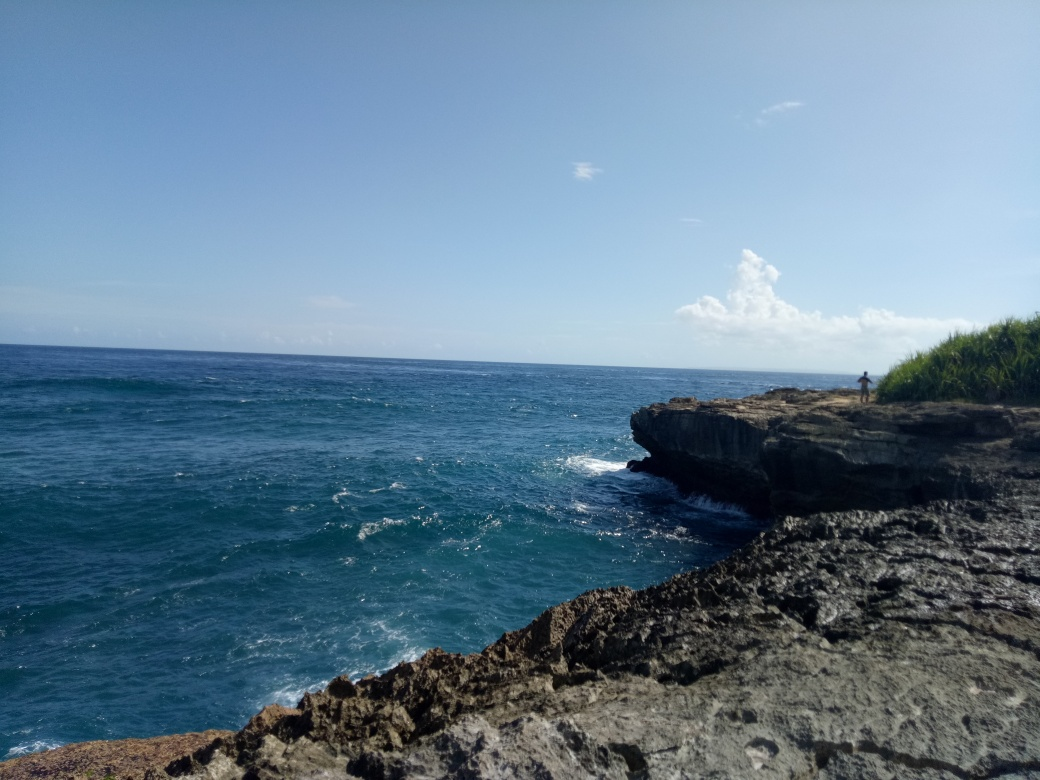What time of day does this image seem to represent? The image suggests it was taken during midday, evidenced by the brightly lit sky and harsh shadows, indicating the sun is high in the sky. 